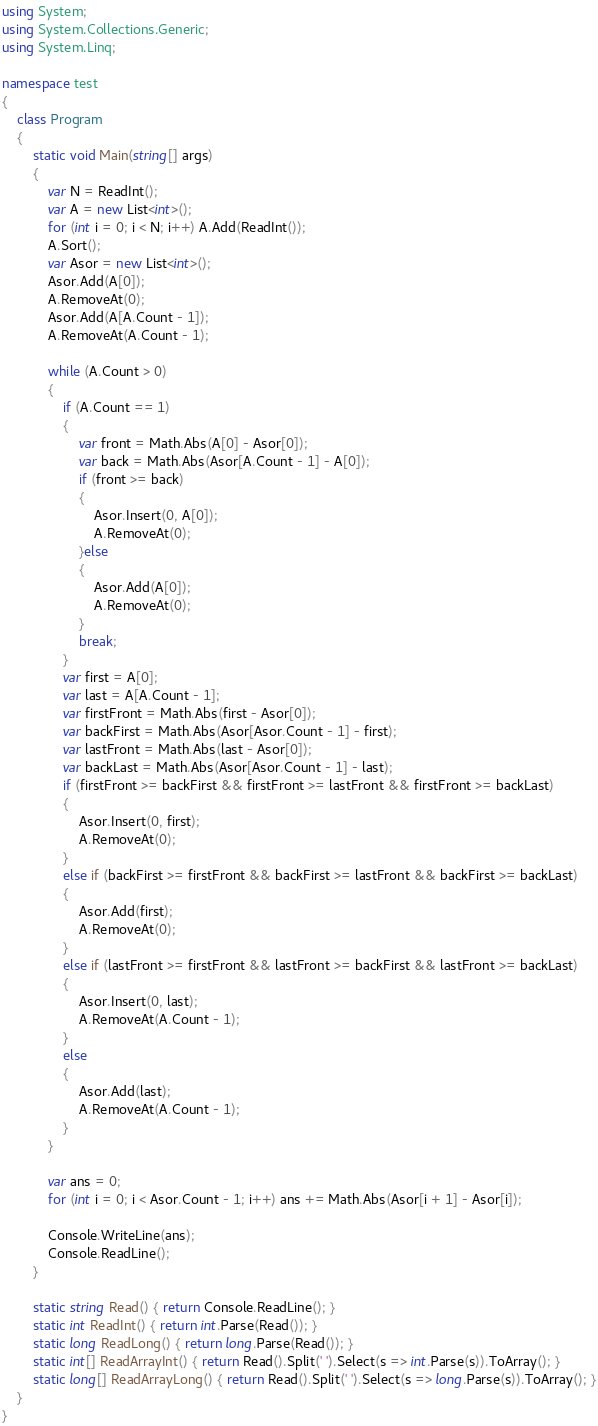<code> <loc_0><loc_0><loc_500><loc_500><_C#_>using System;
using System.Collections.Generic;
using System.Linq;

namespace test
{
    class Program
    {
        static void Main(string[] args)
        {
            var N = ReadInt();
            var A = new List<int>();
            for (int i = 0; i < N; i++) A.Add(ReadInt());
            A.Sort();
            var Asor = new List<int>();
            Asor.Add(A[0]);
            A.RemoveAt(0);
            Asor.Add(A[A.Count - 1]);
            A.RemoveAt(A.Count - 1);

            while (A.Count > 0)
            {
                if (A.Count == 1)
                {
                    var front = Math.Abs(A[0] - Asor[0]);
                    var back = Math.Abs(Asor[A.Count - 1] - A[0]);
                    if (front >= back)
                    {
                        Asor.Insert(0, A[0]);
                        A.RemoveAt(0);
                    }else
                    {
                        Asor.Add(A[0]);
                        A.RemoveAt(0);
                    }
                    break;
                }
                var first = A[0];
                var last = A[A.Count - 1];
                var firstFront = Math.Abs(first - Asor[0]);
                var backFirst = Math.Abs(Asor[Asor.Count - 1] - first);
                var lastFront = Math.Abs(last - Asor[0]);
                var backLast = Math.Abs(Asor[Asor.Count - 1] - last);
                if (firstFront >= backFirst && firstFront >= lastFront && firstFront >= backLast)
                {
                    Asor.Insert(0, first);
                    A.RemoveAt(0);
                }
                else if (backFirst >= firstFront && backFirst >= lastFront && backFirst >= backLast)
                {
                    Asor.Add(first);
                    A.RemoveAt(0);
                }
                else if (lastFront >= firstFront && lastFront >= backFirst && lastFront >= backLast)
                {
                    Asor.Insert(0, last);
                    A.RemoveAt(A.Count - 1);
                }
                else
                {
                    Asor.Add(last);
                    A.RemoveAt(A.Count - 1);
                }
            }

            var ans = 0;
            for (int i = 0; i < Asor.Count - 1; i++) ans += Math.Abs(Asor[i + 1] - Asor[i]);

            Console.WriteLine(ans);
            Console.ReadLine();
        }

        static string Read() { return Console.ReadLine(); }
        static int ReadInt() { return int.Parse(Read()); }
        static long ReadLong() { return long.Parse(Read()); }
        static int[] ReadArrayInt() { return Read().Split(' ').Select(s => int.Parse(s)).ToArray(); }
        static long[] ReadArrayLong() { return Read().Split(' ').Select(s => long.Parse(s)).ToArray(); }
    }
}</code> 